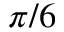<formula> <loc_0><loc_0><loc_500><loc_500>\pi / 6</formula> 